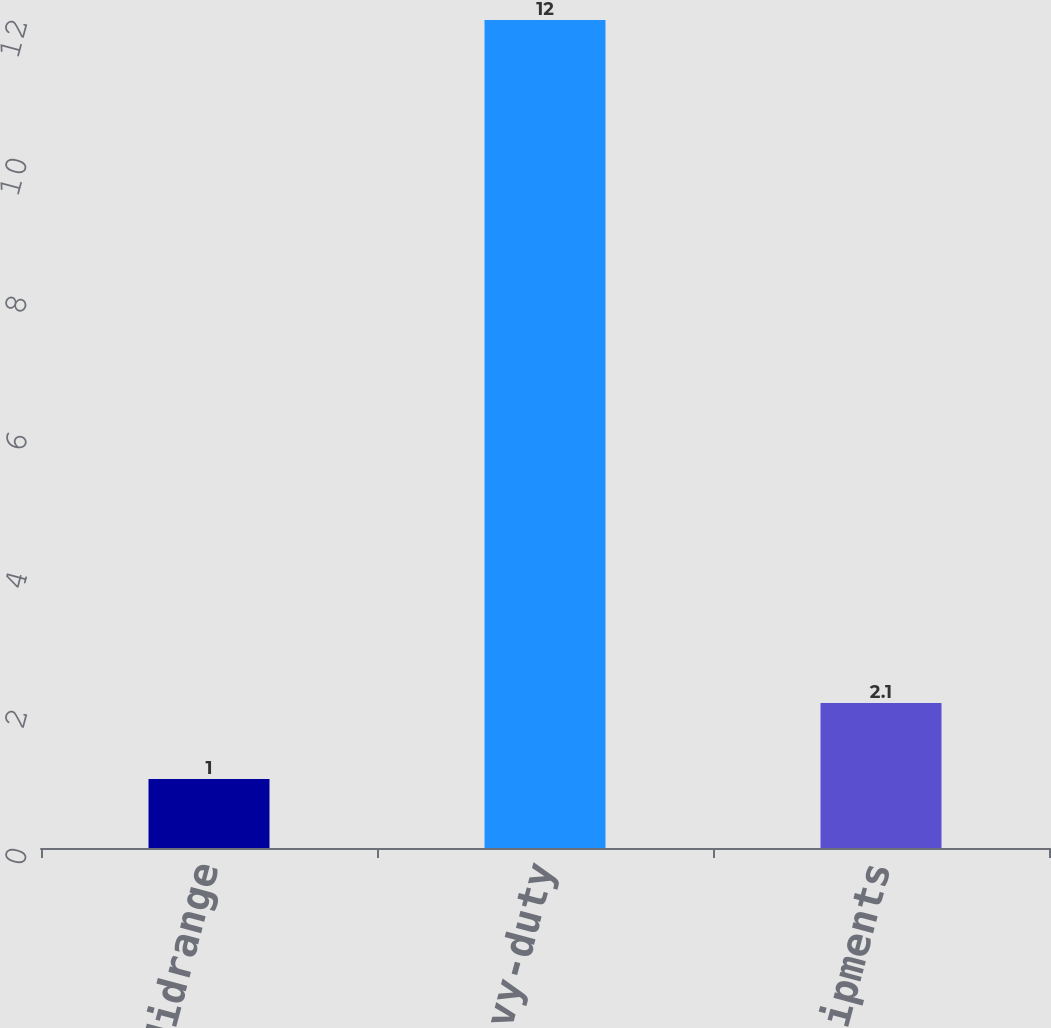<chart> <loc_0><loc_0><loc_500><loc_500><bar_chart><fcel>Midrange<fcel>Heavy-duty<fcel>Total unit shipments<nl><fcel>1<fcel>12<fcel>2.1<nl></chart> 